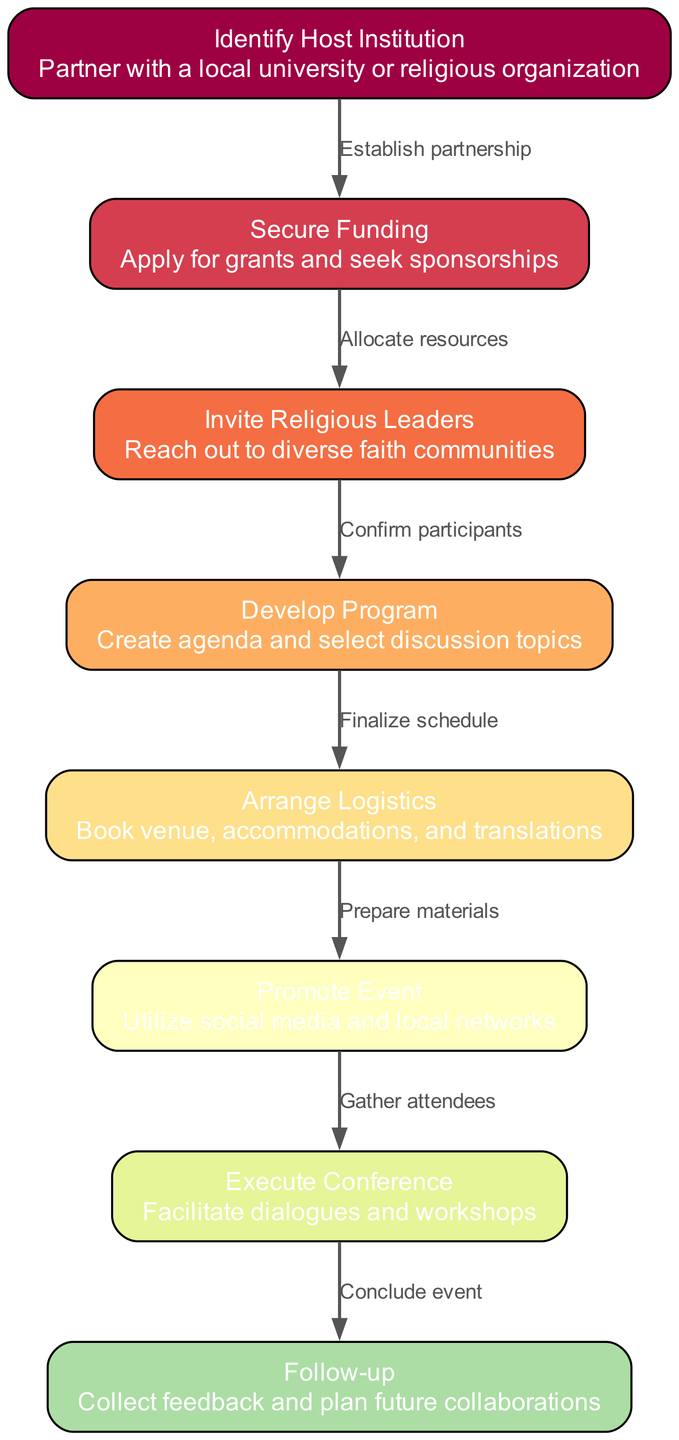What is the first step in the process? The diagram indicates that the first step is to identify the host institution. This is represented as node 1 in the flow chart.
Answer: Identify Host Institution How many nodes are there in the diagram? By counting the nodes listed in the data provided, there are a total of 8 nodes in the diagram.
Answer: 8 What is the relationship between securing funding and inviting religious leaders? The edges connect node 2 (Secure Funding) to node 3 (Invite Religious Leaders) with the label "Allocate resources," indicating that after securing funding, resources can be allocated to invite leaders.
Answer: Allocate resources What is the last step of the process flow? The final step is indicated as node 8, which is Follow-up. It represents the last action taken after executing the conference, leading into future preparations.
Answer: Follow-up Which node comes after developing the program? The flow indicates that after developing the program, the next step is to arrange logistics, which corresponds to node 5.
Answer: Arrange Logistics What is the primary goal of the event represented in the diagram? The overall goal of organizing the interfaith dialogue conference is articulated through the execution of the conference, where diverse faith communities engage in dialogue.
Answer: Execute Conference How many edges connect to the node for promoting the event? The node for promoting the event (node 6) has one incoming edge from node 5 (Arrange Logistics) and one outgoing edge to node 7 (Execute Conference), totaling 2 edges connected.
Answer: 2 Which two nodes are directly connected without any intermediate steps? The nodes for securing funding (node 2) and inviting religious leaders (node 3) are directly connected by the edge labeled "Allocate resources."
Answer: Secure Funding and Invite Religious Leaders 